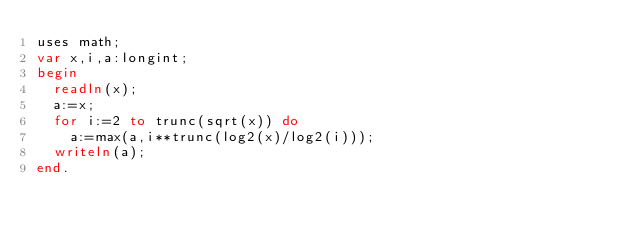<code> <loc_0><loc_0><loc_500><loc_500><_Pascal_>uses math;
var x,i,a:longint;
begin
  readln(x);
  a:=x;
  for i:=2 to trunc(sqrt(x)) do
    a:=max(a,i**trunc(log2(x)/log2(i)));
  writeln(a);
end.</code> 